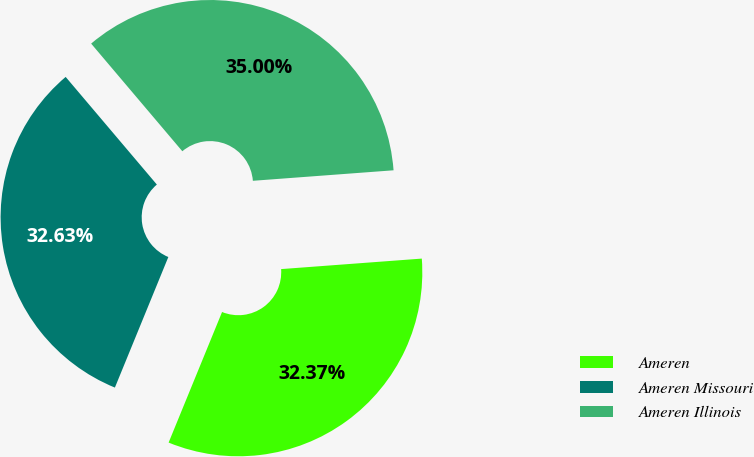Convert chart to OTSL. <chart><loc_0><loc_0><loc_500><loc_500><pie_chart><fcel>Ameren<fcel>Ameren Missouri<fcel>Ameren Illinois<nl><fcel>32.37%<fcel>32.63%<fcel>35.0%<nl></chart> 